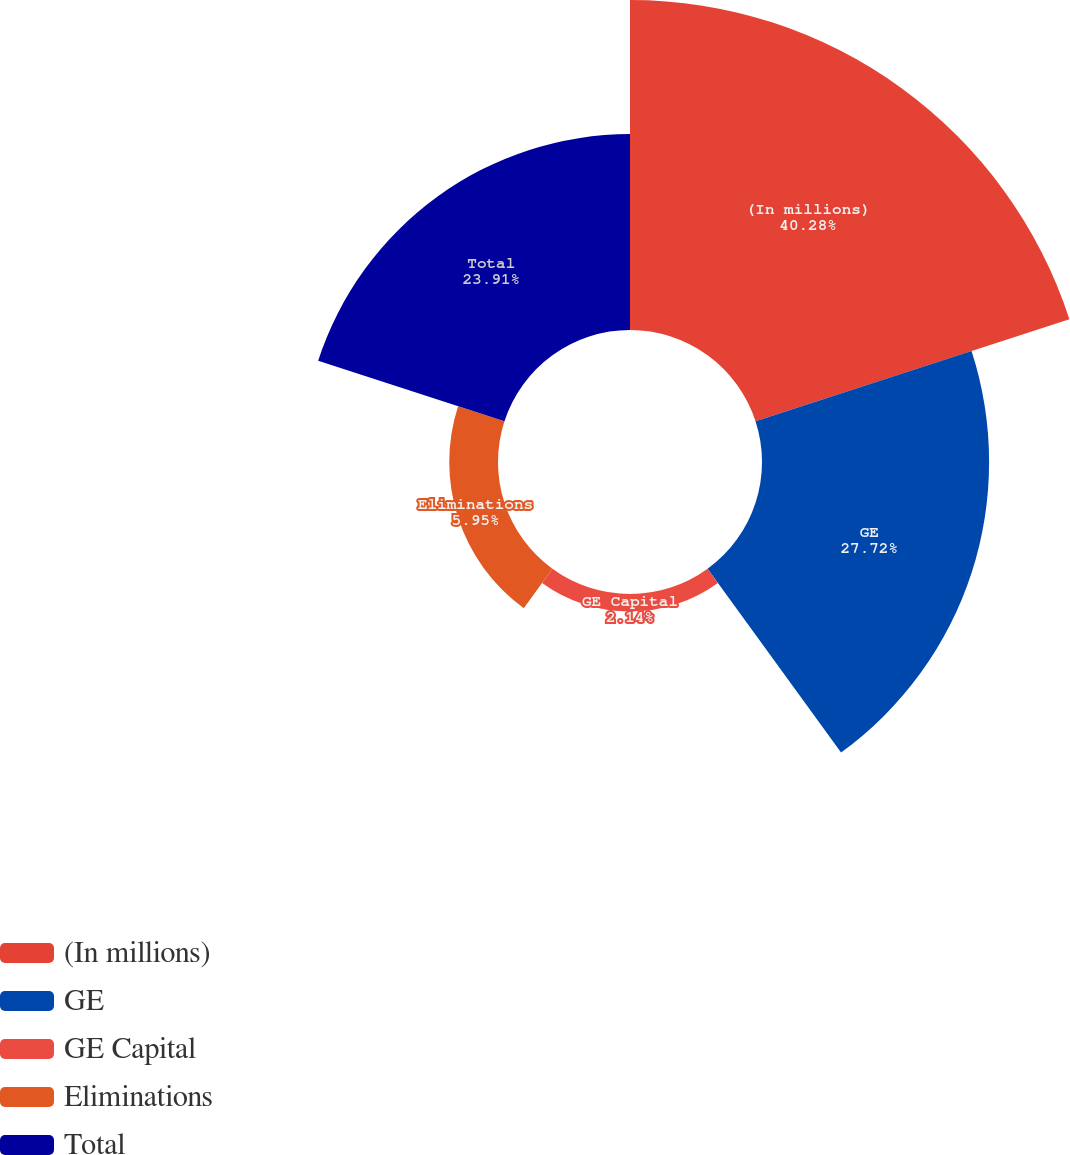Convert chart to OTSL. <chart><loc_0><loc_0><loc_500><loc_500><pie_chart><fcel>(In millions)<fcel>GE<fcel>GE Capital<fcel>Eliminations<fcel>Total<nl><fcel>40.28%<fcel>27.72%<fcel>2.14%<fcel>5.95%<fcel>23.91%<nl></chart> 